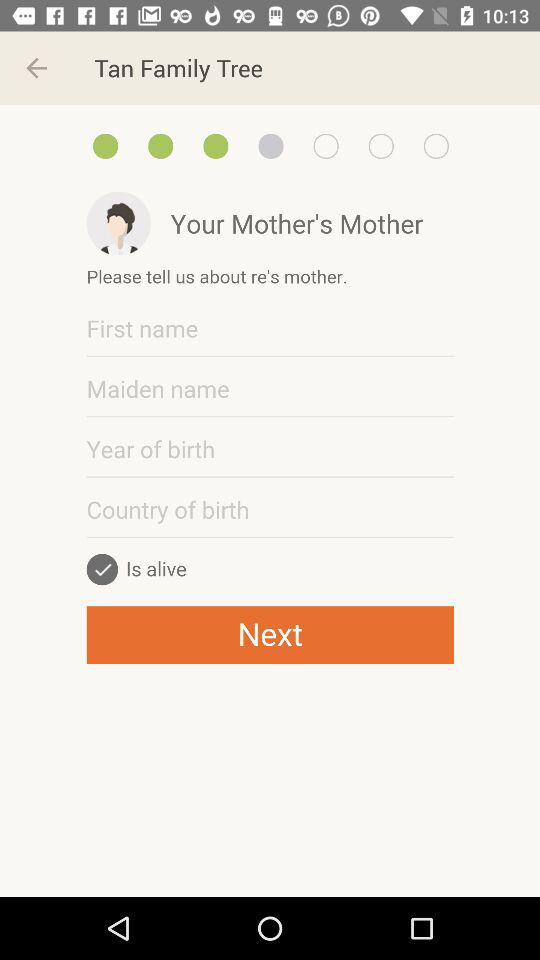How many fields are there for information about the mother's mother?
Answer the question using a single word or phrase. 4 